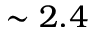Convert formula to latex. <formula><loc_0><loc_0><loc_500><loc_500>\sim 2 . 4</formula> 